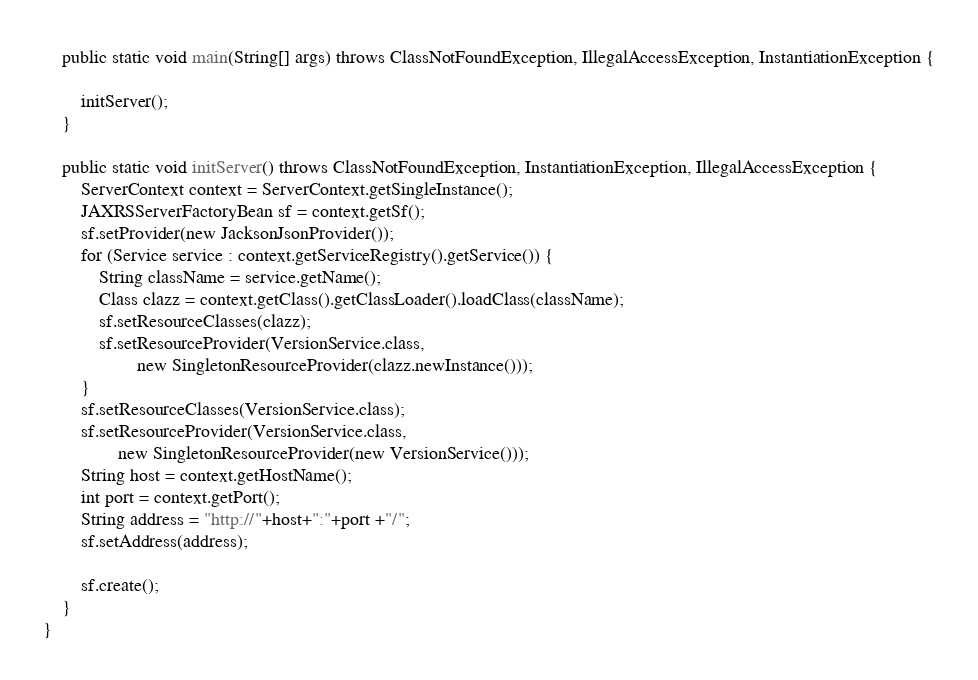<code> <loc_0><loc_0><loc_500><loc_500><_Java_>
    public static void main(String[] args) throws ClassNotFoundException, IllegalAccessException, InstantiationException {

        initServer();
    }

    public static void initServer() throws ClassNotFoundException, InstantiationException, IllegalAccessException {
        ServerContext context = ServerContext.getSingleInstance();
        JAXRSServerFactoryBean sf = context.getSf();
        sf.setProvider(new JacksonJsonProvider());
        for (Service service : context.getServiceRegistry().getService()) {
            String className = service.getName();
            Class clazz = context.getClass().getClassLoader().loadClass(className);
            sf.setResourceClasses(clazz);
            sf.setResourceProvider(VersionService.class,
                    new SingletonResourceProvider(clazz.newInstance()));
        }
        sf.setResourceClasses(VersionService.class);
        sf.setResourceProvider(VersionService.class,
                new SingletonResourceProvider(new VersionService()));
        String host = context.getHostName();
        int port = context.getPort();
        String address = "http://"+host+":"+port +"/";
        sf.setAddress(address);

        sf.create();
    }
}
</code> 